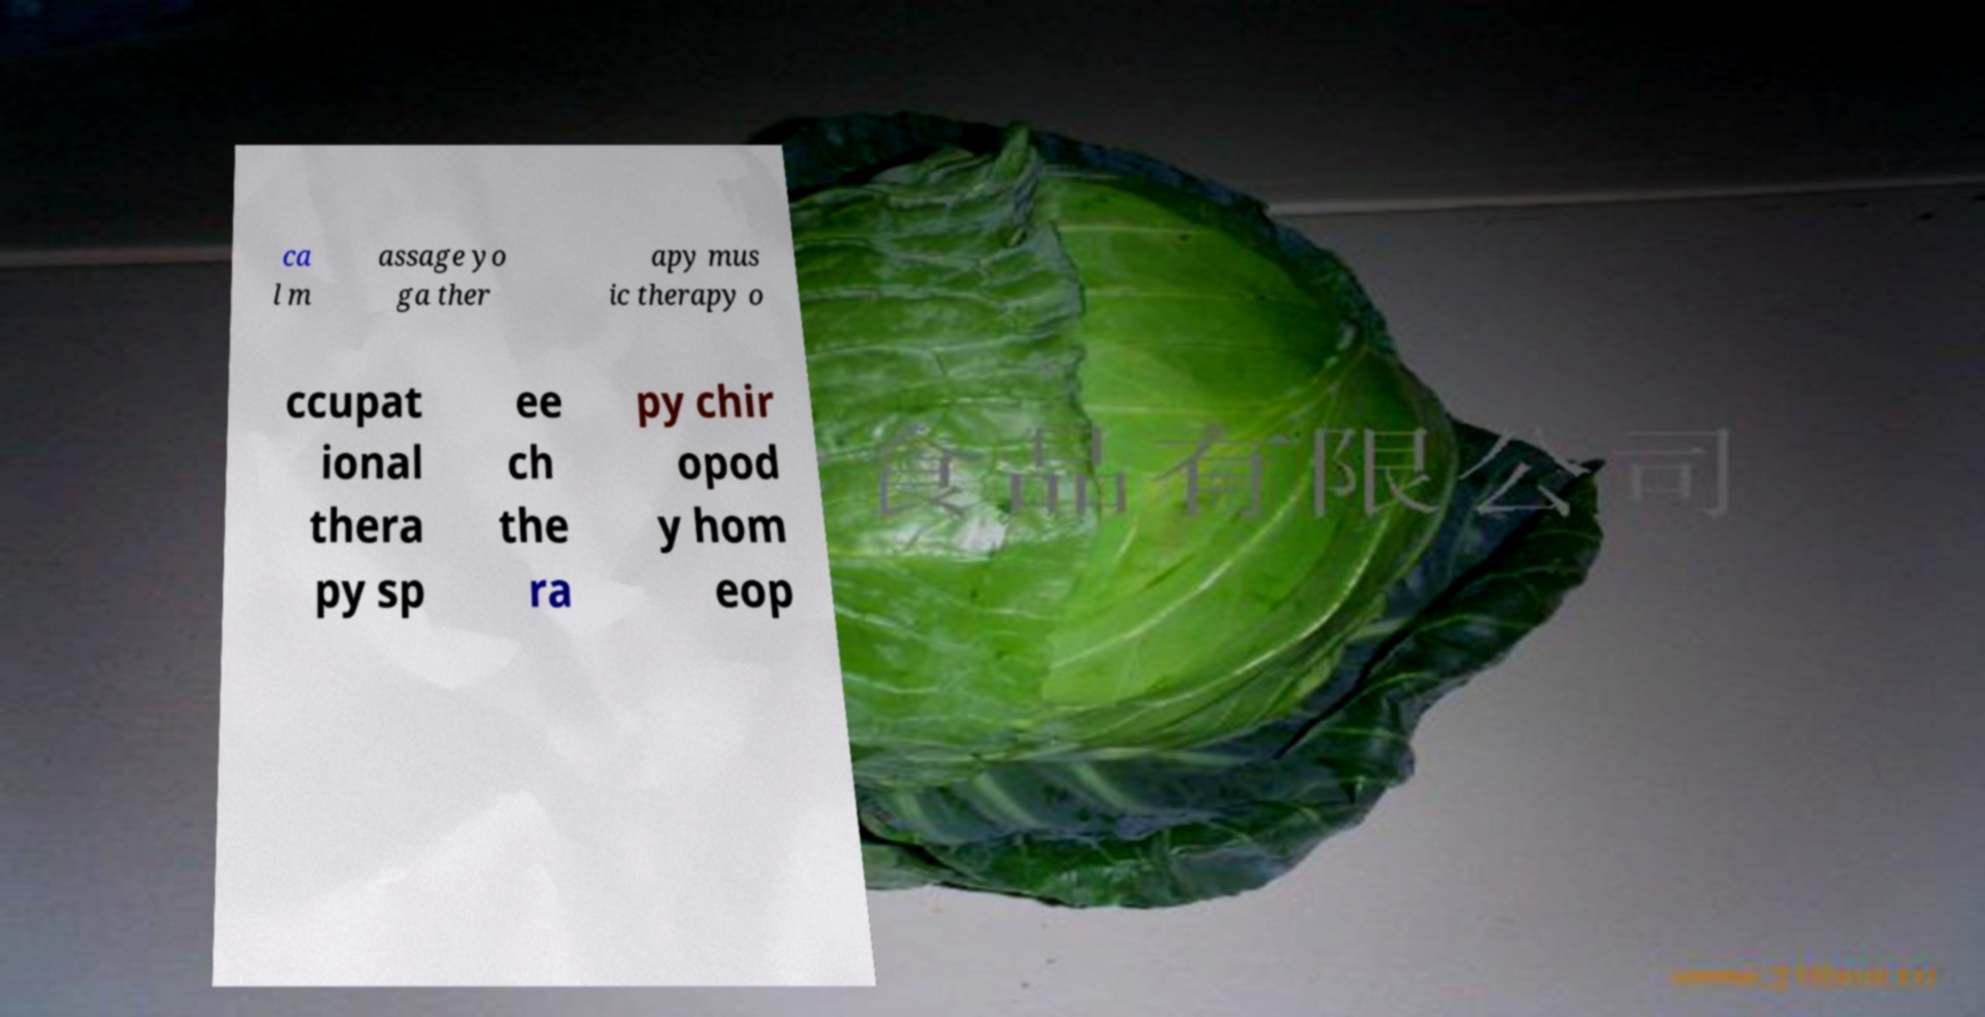There's text embedded in this image that I need extracted. Can you transcribe it verbatim? ca l m assage yo ga ther apy mus ic therapy o ccupat ional thera py sp ee ch the ra py chir opod y hom eop 